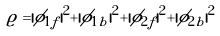<formula> <loc_0><loc_0><loc_500><loc_500>\varrho = | \phi _ { 1 f } | ^ { 2 } + | \phi _ { 1 b } | ^ { 2 } + | \phi _ { 2 f } | ^ { 2 } + | \phi _ { 2 b } | ^ { 2 }</formula> 